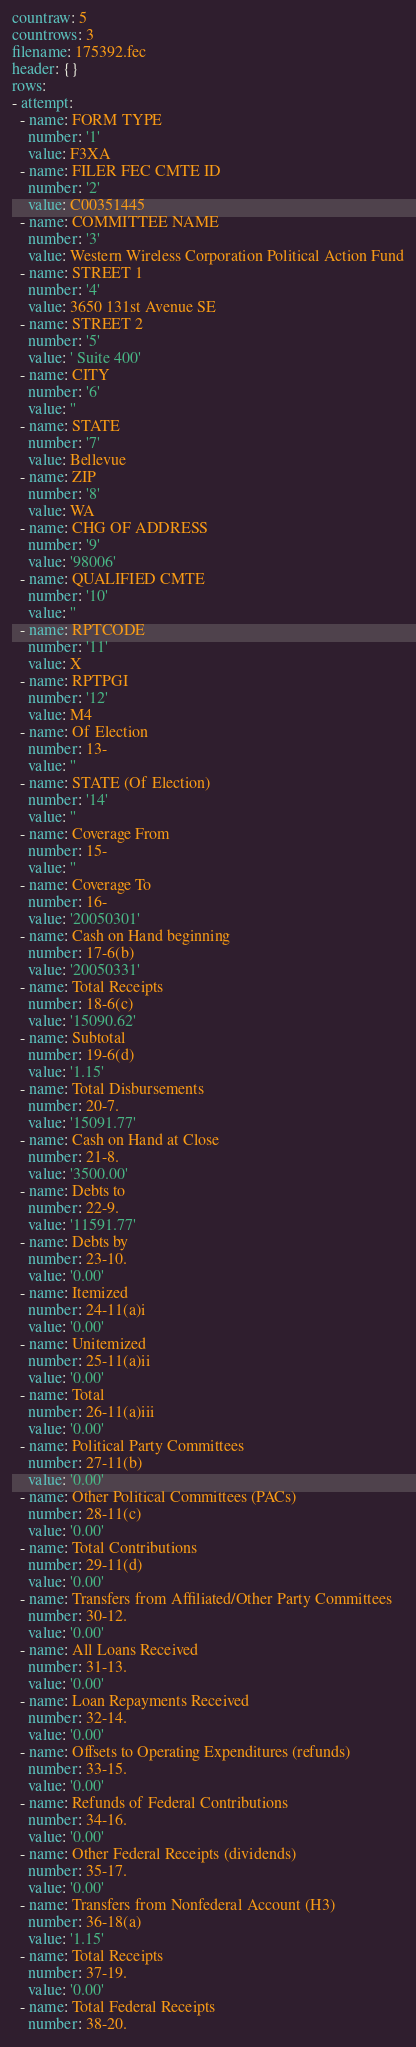<code> <loc_0><loc_0><loc_500><loc_500><_YAML_>countraw: 5
countrows: 3
filename: 175392.fec
header: {}
rows:
- attempt:
  - name: FORM TYPE
    number: '1'
    value: F3XA
  - name: FILER FEC CMTE ID
    number: '2'
    value: C00351445
  - name: COMMITTEE NAME
    number: '3'
    value: Western Wireless Corporation Political Action Fund
  - name: STREET 1
    number: '4'
    value: 3650 131st Avenue SE
  - name: STREET 2
    number: '5'
    value: ' Suite 400'
  - name: CITY
    number: '6'
    value: ''
  - name: STATE
    number: '7'
    value: Bellevue
  - name: ZIP
    number: '8'
    value: WA
  - name: CHG OF ADDRESS
    number: '9'
    value: '98006'
  - name: QUALIFIED CMTE
    number: '10'
    value: ''
  - name: RPTCODE
    number: '11'
    value: X
  - name: RPTPGI
    number: '12'
    value: M4
  - name: Of Election
    number: 13-
    value: ''
  - name: STATE (Of Election)
    number: '14'
    value: ''
  - name: Coverage From
    number: 15-
    value: ''
  - name: Coverage To
    number: 16-
    value: '20050301'
  - name: Cash on Hand beginning
    number: 17-6(b)
    value: '20050331'
  - name: Total Receipts
    number: 18-6(c)
    value: '15090.62'
  - name: Subtotal
    number: 19-6(d)
    value: '1.15'
  - name: Total Disbursements
    number: 20-7.
    value: '15091.77'
  - name: Cash on Hand at Close
    number: 21-8.
    value: '3500.00'
  - name: Debts to
    number: 22-9.
    value: '11591.77'
  - name: Debts by
    number: 23-10.
    value: '0.00'
  - name: Itemized
    number: 24-11(a)i
    value: '0.00'
  - name: Unitemized
    number: 25-11(a)ii
    value: '0.00'
  - name: Total
    number: 26-11(a)iii
    value: '0.00'
  - name: Political Party Committees
    number: 27-11(b)
    value: '0.00'
  - name: Other Political Committees (PACs)
    number: 28-11(c)
    value: '0.00'
  - name: Total Contributions
    number: 29-11(d)
    value: '0.00'
  - name: Transfers from Affiliated/Other Party Committees
    number: 30-12.
    value: '0.00'
  - name: All Loans Received
    number: 31-13.
    value: '0.00'
  - name: Loan Repayments Received
    number: 32-14.
    value: '0.00'
  - name: Offsets to Operating Expenditures (refunds)
    number: 33-15.
    value: '0.00'
  - name: Refunds of Federal Contributions
    number: 34-16.
    value: '0.00'
  - name: Other Federal Receipts (dividends)
    number: 35-17.
    value: '0.00'
  - name: Transfers from Nonfederal Account (H3)
    number: 36-18(a)
    value: '1.15'
  - name: Total Receipts
    number: 37-19.
    value: '0.00'
  - name: Total Federal Receipts
    number: 38-20.</code> 